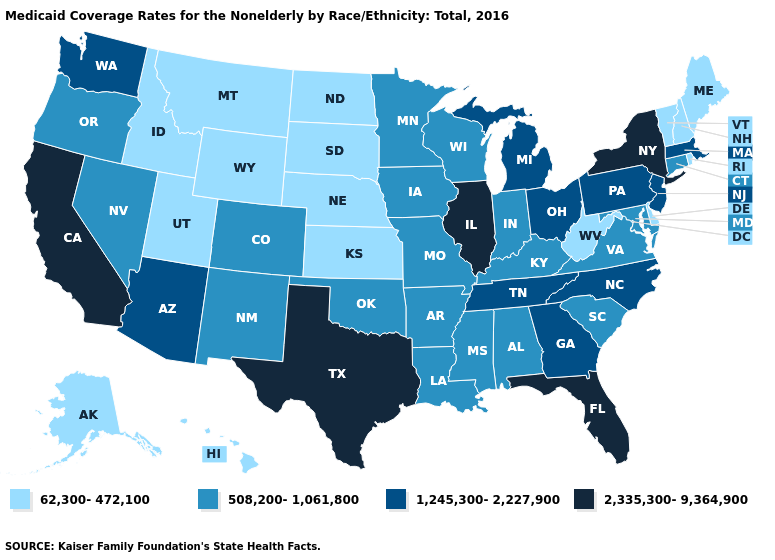What is the value of Arizona?
Short answer required. 1,245,300-2,227,900. What is the highest value in states that border West Virginia?
Concise answer only. 1,245,300-2,227,900. What is the value of Delaware?
Short answer required. 62,300-472,100. Name the states that have a value in the range 1,245,300-2,227,900?
Give a very brief answer. Arizona, Georgia, Massachusetts, Michigan, New Jersey, North Carolina, Ohio, Pennsylvania, Tennessee, Washington. Among the states that border California , which have the highest value?
Give a very brief answer. Arizona. Name the states that have a value in the range 508,200-1,061,800?
Quick response, please. Alabama, Arkansas, Colorado, Connecticut, Indiana, Iowa, Kentucky, Louisiana, Maryland, Minnesota, Mississippi, Missouri, Nevada, New Mexico, Oklahoma, Oregon, South Carolina, Virginia, Wisconsin. Name the states that have a value in the range 1,245,300-2,227,900?
Write a very short answer. Arizona, Georgia, Massachusetts, Michigan, New Jersey, North Carolina, Ohio, Pennsylvania, Tennessee, Washington. What is the value of Maine?
Write a very short answer. 62,300-472,100. Does the map have missing data?
Write a very short answer. No. Which states have the lowest value in the Northeast?
Concise answer only. Maine, New Hampshire, Rhode Island, Vermont. Among the states that border Nevada , which have the highest value?
Be succinct. California. Name the states that have a value in the range 2,335,300-9,364,900?
Quick response, please. California, Florida, Illinois, New York, Texas. What is the value of Iowa?
Short answer required. 508,200-1,061,800. What is the highest value in the MidWest ?
Answer briefly. 2,335,300-9,364,900. 